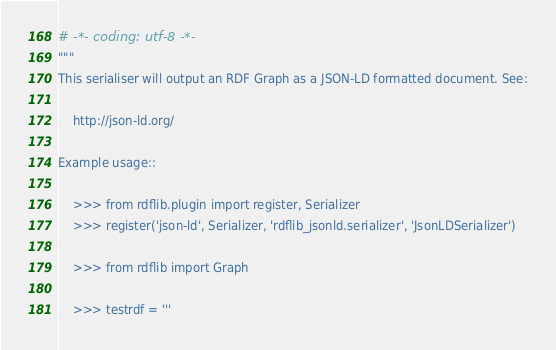<code> <loc_0><loc_0><loc_500><loc_500><_Python_># -*- coding: utf-8 -*-
"""
This serialiser will output an RDF Graph as a JSON-LD formatted document. See:

    http://json-ld.org/

Example usage::

    >>> from rdflib.plugin import register, Serializer
    >>> register('json-ld', Serializer, 'rdflib_jsonld.serializer', 'JsonLDSerializer')

    >>> from rdflib import Graph

    >>> testrdf = '''</code> 